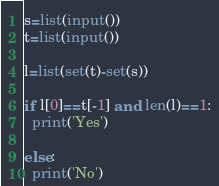<code> <loc_0><loc_0><loc_500><loc_500><_Python_>s=list(input())
t=list(input())

l=list(set(t)-set(s))

if l[0]==t[-1] and len(l)==1:
  print('Yes')
  
else:
  print('No')
</code> 